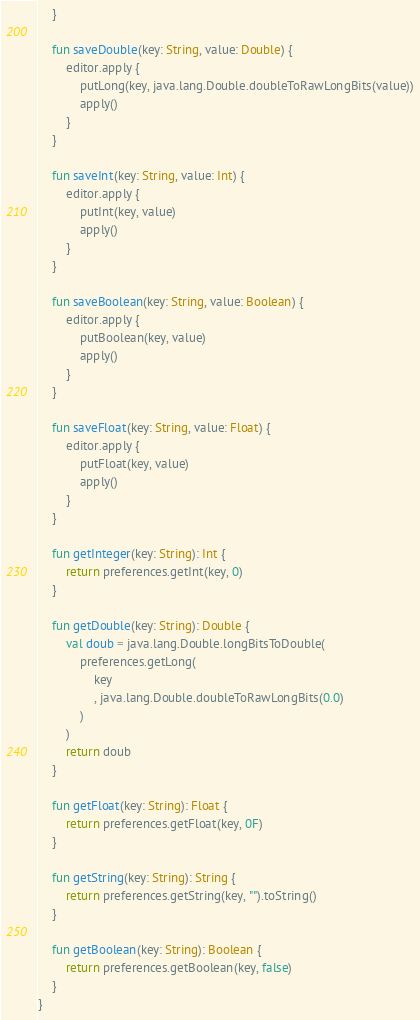<code> <loc_0><loc_0><loc_500><loc_500><_Kotlin_>    }

    fun saveDouble(key: String, value: Double) {
        editor.apply {
            putLong(key, java.lang.Double.doubleToRawLongBits(value))
            apply()
        }
    }

    fun saveInt(key: String, value: Int) {
        editor.apply {
            putInt(key, value)
            apply()
        }
    }

    fun saveBoolean(key: String, value: Boolean) {
        editor.apply {
            putBoolean(key, value)
            apply()
        }
    }

    fun saveFloat(key: String, value: Float) {
        editor.apply {
            putFloat(key, value)
            apply()
        }
    }

    fun getInteger(key: String): Int {
        return preferences.getInt(key, 0)
    }

    fun getDouble(key: String): Double {
        val doub = java.lang.Double.longBitsToDouble(
            preferences.getLong(
                key
                , java.lang.Double.doubleToRawLongBits(0.0)
            )
        )
        return doub
    }

    fun getFloat(key: String): Float {
        return preferences.getFloat(key, 0F)
    }

    fun getString(key: String): String {
        return preferences.getString(key, "").toString()
    }

    fun getBoolean(key: String): Boolean {
        return preferences.getBoolean(key, false)
    }
}</code> 